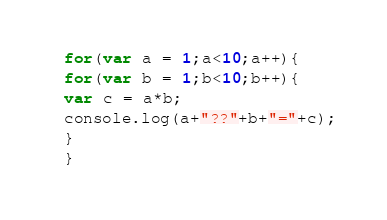Convert code to text. <code><loc_0><loc_0><loc_500><loc_500><_JavaScript_>for(var a = 1;a<10;a++){
for(var b = 1;b<10;b++){
var c = a*b;
console.log(a+"??"+b+"="+c);
}
}</code> 